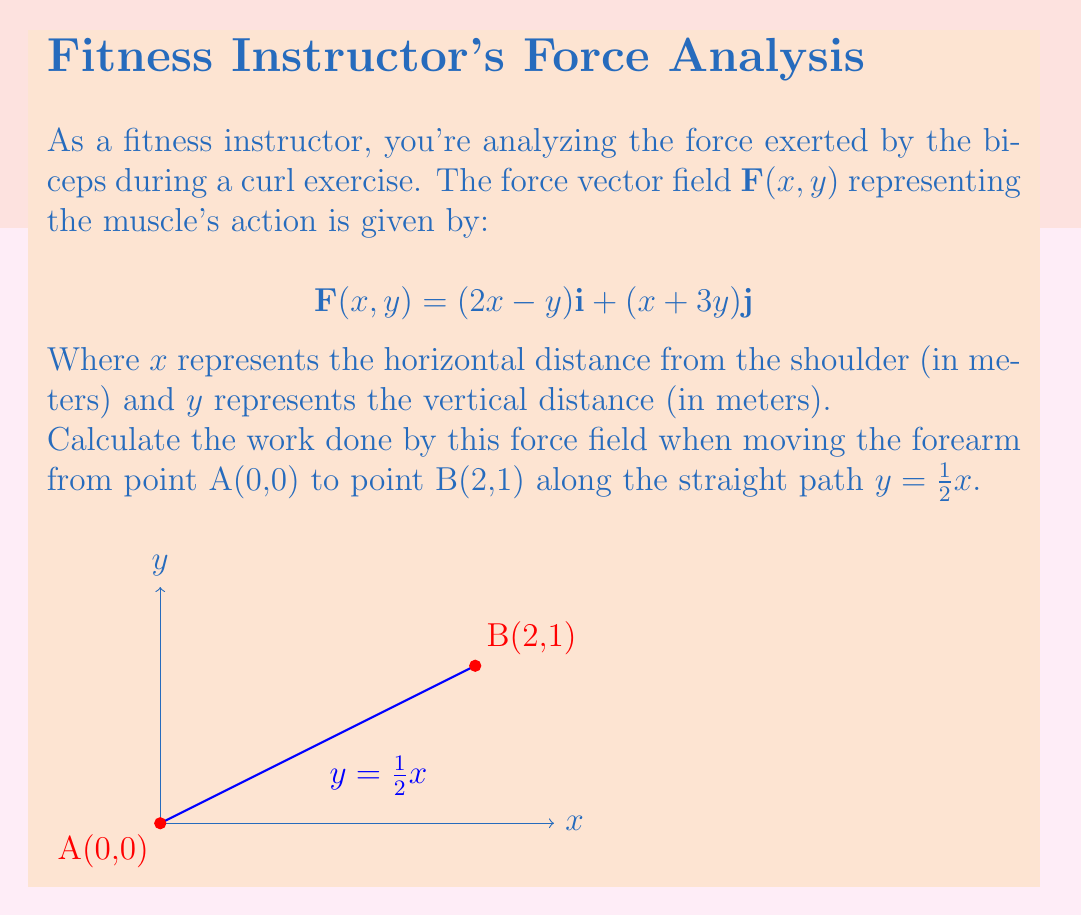What is the answer to this math problem? Let's approach this step-by-step:

1) The work done by a force field along a path is given by the line integral:

   $$W = \int_C \mathbf{F} \cdot d\mathbf{r}$$

2) We need to parameterize the path. Since it's a straight line from (0,0) to (2,1), we can use:
   
   $$x = t, y = \frac{1}{2}t, 0 \leq t \leq 2$$

3) The differential $d\mathbf{r}$ is:

   $$d\mathbf{r} = dx\mathbf{i} + dy\mathbf{j} = dt\mathbf{i} + \frac{1}{2}dt\mathbf{j}$$

4) Substituting the parametric equations into $\mathbf{F}$:

   $$\mathbf{F}(t) = (2t-\frac{1}{2}t)\mathbf{i} + (t+\frac{3}{2}t)\mathbf{j} = \frac{3t}{2}\mathbf{i} + \frac{5t}{2}\mathbf{j}$$

5) Now, we can calculate the dot product $\mathbf{F} \cdot d\mathbf{r}$:

   $$\mathbf{F} \cdot d\mathbf{r} = (\frac{3t}{2}\mathbf{i} + \frac{5t}{2}\mathbf{j}) \cdot (dt\mathbf{i} + \frac{1}{2}dt\mathbf{j}) = \frac{3t}{2}dt + \frac{5t}{4}dt = \frac{9t}{4}dt$$

6) Now we can integrate:

   $$W = \int_0^2 \frac{9t}{4}dt = \frac{9}{4} \int_0^2 tdt = \frac{9}{4} \cdot \frac{t^2}{2}\bigg|_0^2 = \frac{9}{4} \cdot 2 = \frac{9}{2}$$

Therefore, the work done is $\frac{9}{2}$ Joules.
Answer: $\frac{9}{2}$ J 